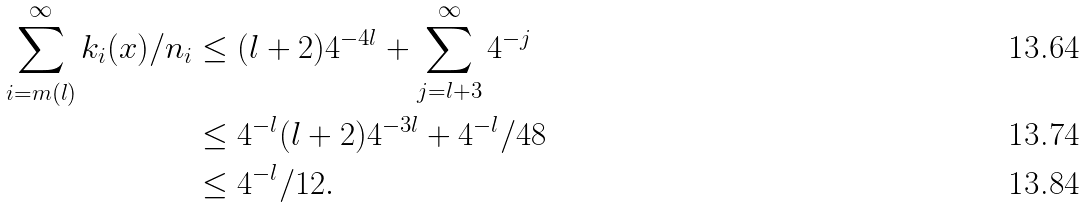<formula> <loc_0><loc_0><loc_500><loc_500>\sum _ { i = m ( l ) } ^ { \infty } k _ { i } ( x ) / n _ { i } & \leq ( l + 2 ) 4 ^ { - 4 l } + \sum _ { j = l + 3 } ^ { \infty } 4 ^ { - j } \\ & \leq 4 ^ { - l } ( l + 2 ) 4 ^ { - 3 l } + 4 ^ { - l } / 4 8 \\ & \leq 4 ^ { - l } / 1 2 .</formula> 